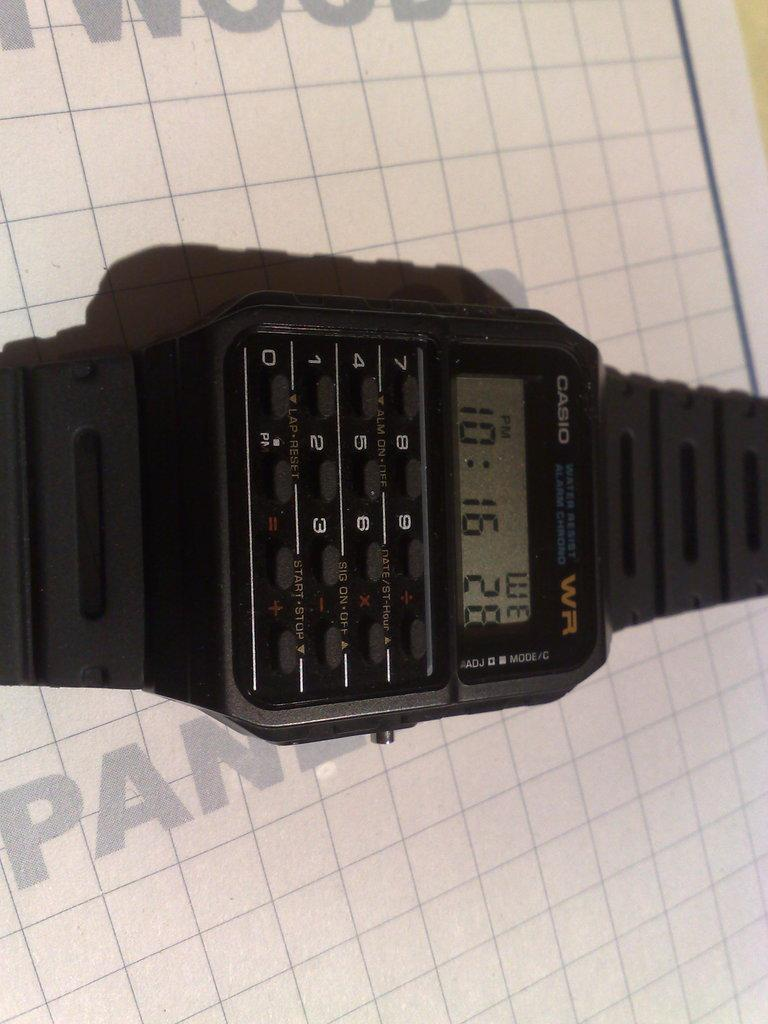<image>
Present a compact description of the photo's key features. An older CASIO brand watch with a calculator on it. 